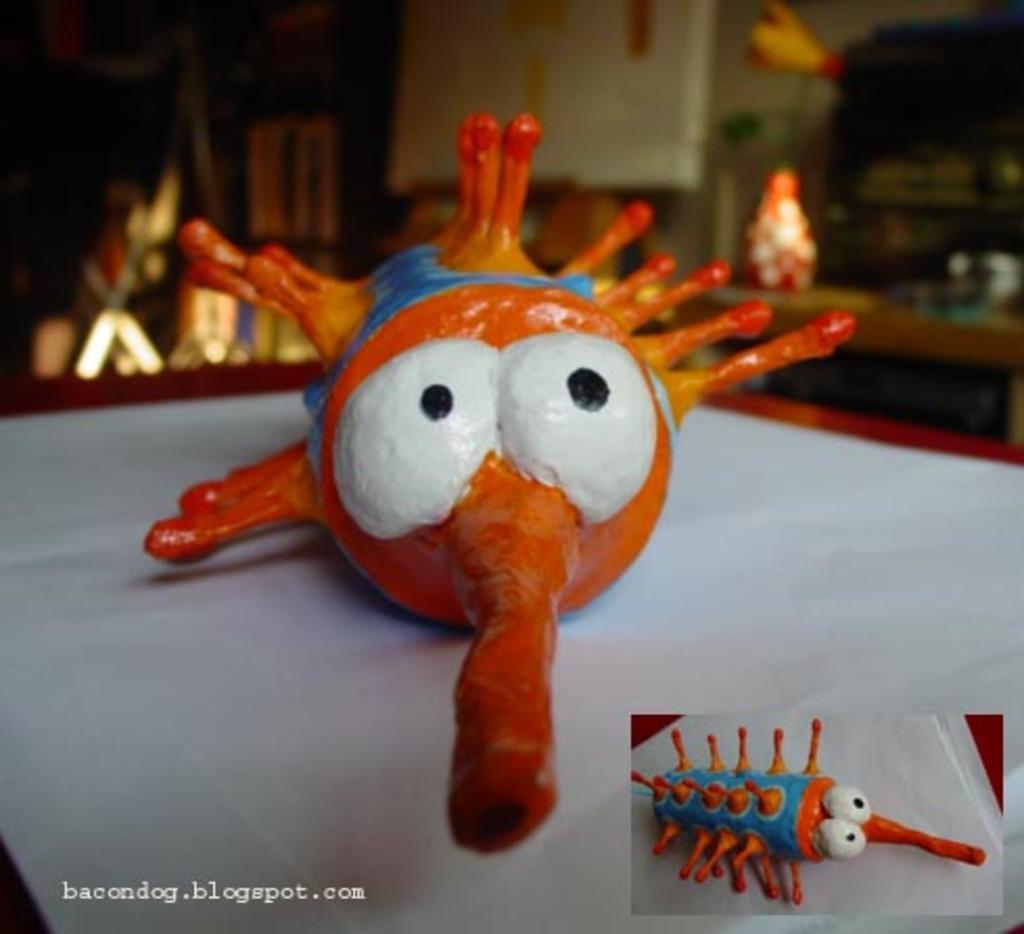How would you summarize this image in a sentence or two? There is a toy in the center of the image and there is a toys's image at the bottom side of the image and there is text at the bottom side of the image. 